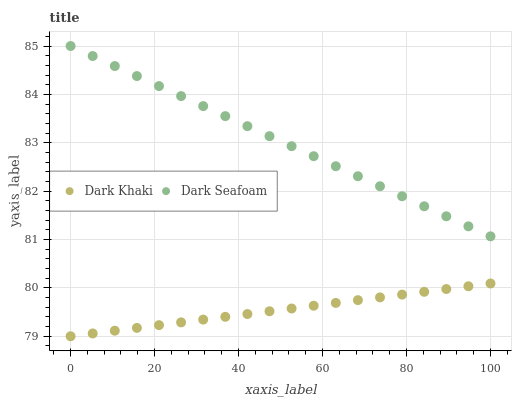Does Dark Khaki have the minimum area under the curve?
Answer yes or no. Yes. Does Dark Seafoam have the maximum area under the curve?
Answer yes or no. Yes. Does Dark Seafoam have the minimum area under the curve?
Answer yes or no. No. Is Dark Khaki the smoothest?
Answer yes or no. Yes. Is Dark Seafoam the roughest?
Answer yes or no. Yes. Is Dark Seafoam the smoothest?
Answer yes or no. No. Does Dark Khaki have the lowest value?
Answer yes or no. Yes. Does Dark Seafoam have the lowest value?
Answer yes or no. No. Does Dark Seafoam have the highest value?
Answer yes or no. Yes. Is Dark Khaki less than Dark Seafoam?
Answer yes or no. Yes. Is Dark Seafoam greater than Dark Khaki?
Answer yes or no. Yes. Does Dark Khaki intersect Dark Seafoam?
Answer yes or no. No. 